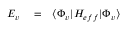<formula> <loc_0><loc_0><loc_500><loc_500>\begin{array} { r l r } { E _ { v } } & = } & { \langle \Phi _ { v } | H _ { e f f } | \Phi _ { v } \rangle } \end{array}</formula> 